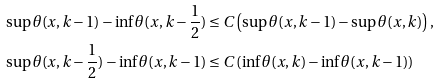<formula> <loc_0><loc_0><loc_500><loc_500>\sup \theta ( x , k - 1 ) - \inf \theta ( x , k - \frac { 1 } { 2 } ) & \leq C \left ( \sup \theta ( x , k - 1 ) - \sup \theta ( x , k ) \right ) , \\ \sup \theta ( x , k - \frac { 1 } { 2 } ) - \inf \theta ( x , k - 1 ) & \leq C \left ( \inf \theta ( x , k ) - \inf \theta ( x , k - 1 ) \right )</formula> 